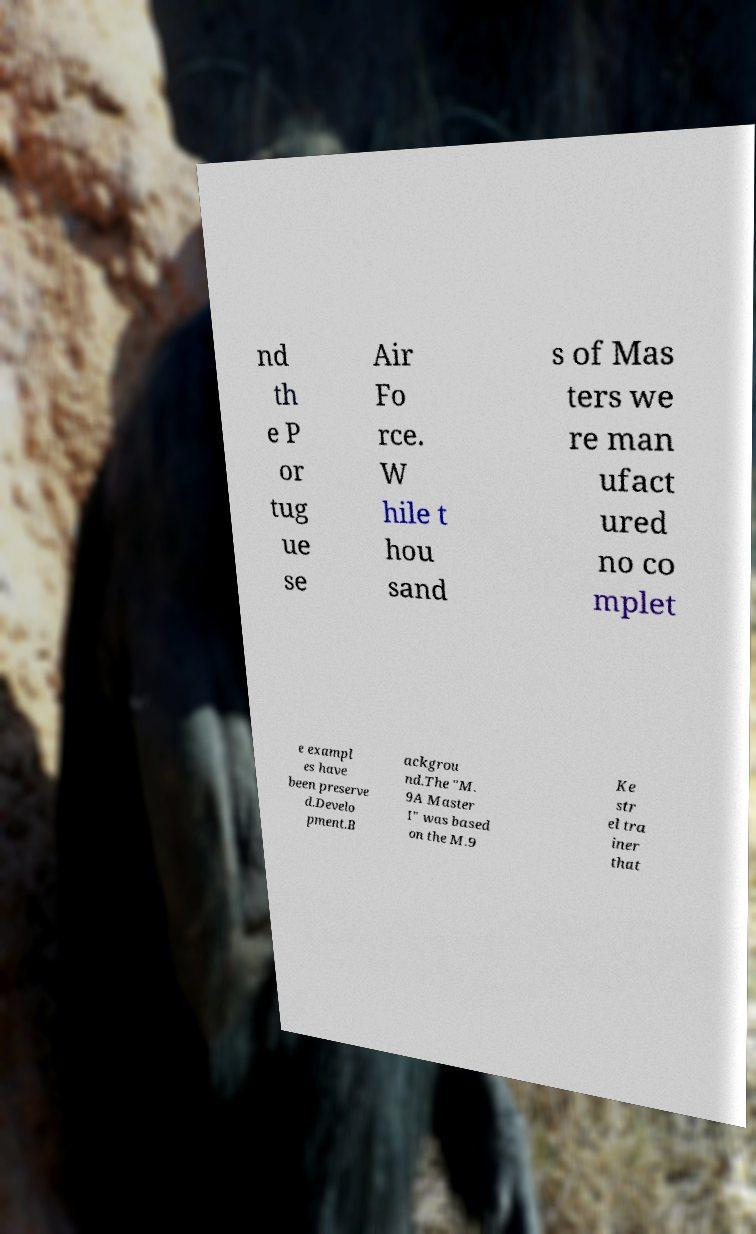What messages or text are displayed in this image? I need them in a readable, typed format. nd th e P or tug ue se Air Fo rce. W hile t hou sand s of Mas ters we re man ufact ured no co mplet e exampl es have been preserve d.Develo pment.B ackgrou nd.The "M. 9A Master I" was based on the M.9 Ke str el tra iner that 